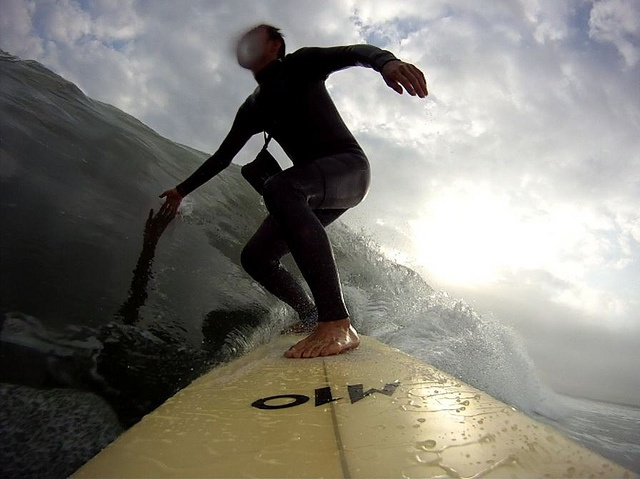Describe the objects in this image and their specific colors. I can see surfboard in gray, tan, and olive tones, people in gray, black, maroon, and darkgray tones, and handbag in gray, black, darkgray, and lightgray tones in this image. 